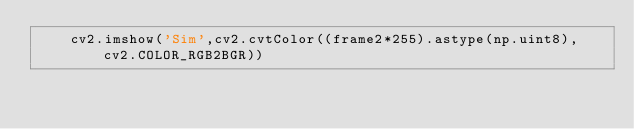<code> <loc_0><loc_0><loc_500><loc_500><_Python_>    cv2.imshow('Sim',cv2.cvtColor((frame2*255).astype(np.uint8), cv2.COLOR_RGB2BGR))</code> 